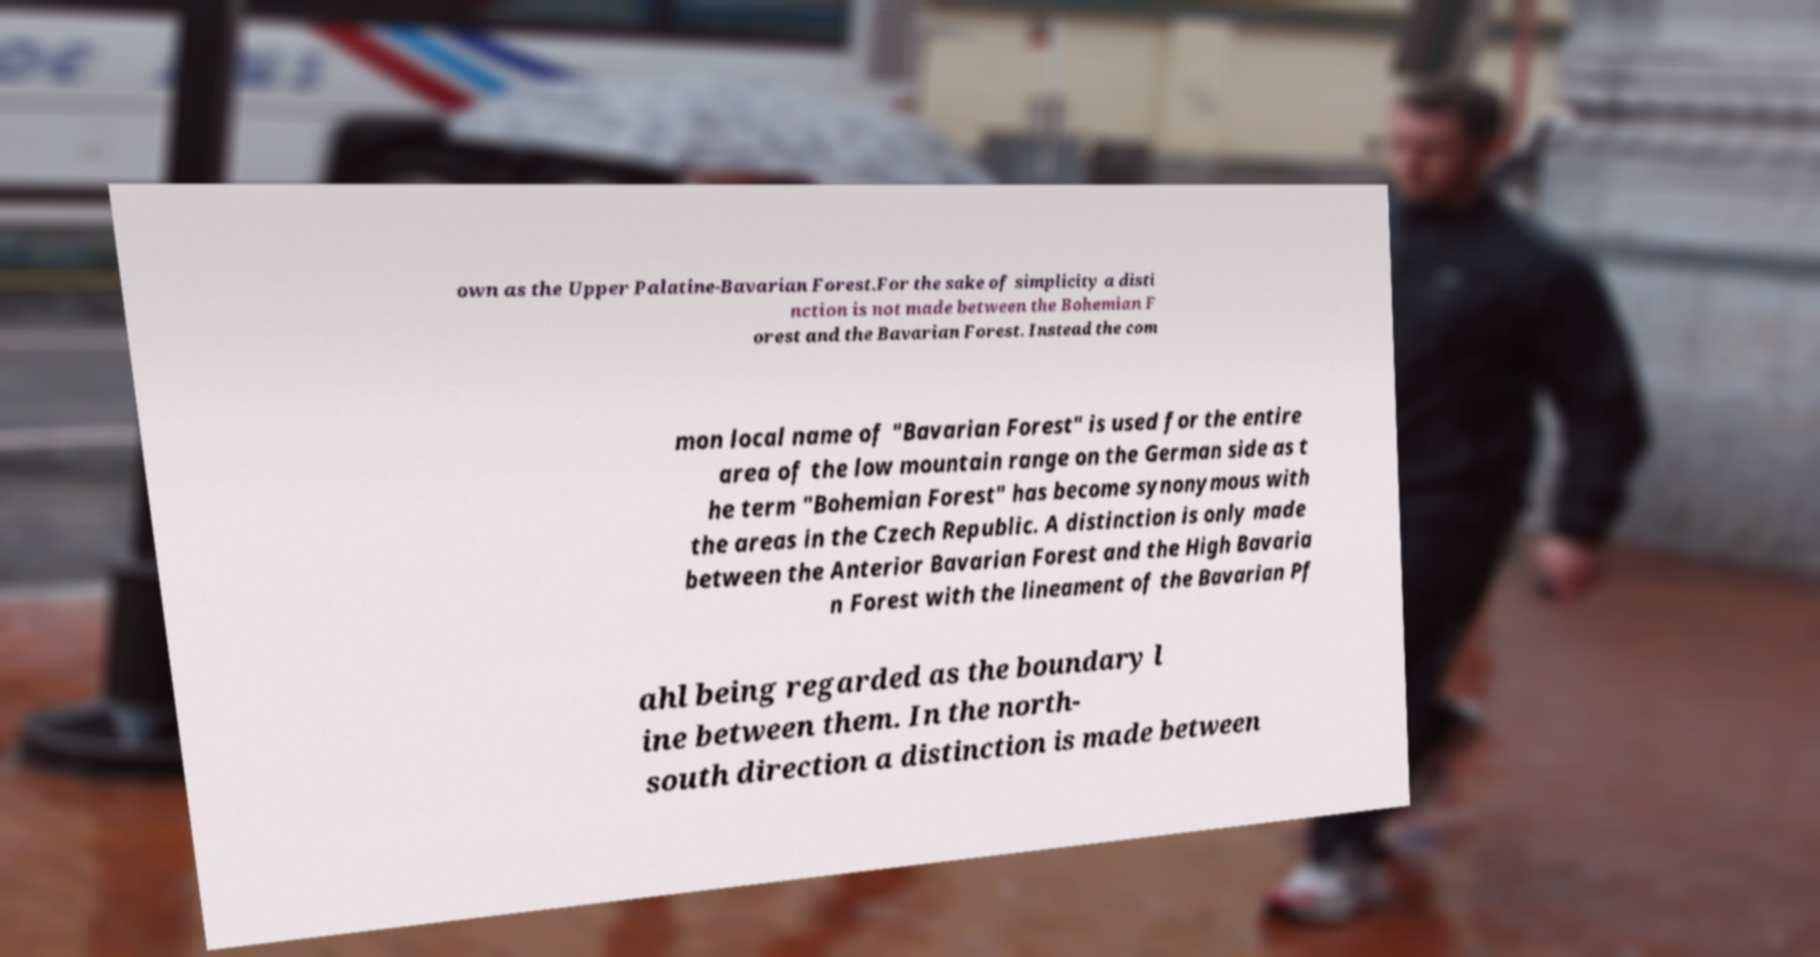Could you assist in decoding the text presented in this image and type it out clearly? own as the Upper Palatine-Bavarian Forest.For the sake of simplicity a disti nction is not made between the Bohemian F orest and the Bavarian Forest. Instead the com mon local name of "Bavarian Forest" is used for the entire area of the low mountain range on the German side as t he term "Bohemian Forest" has become synonymous with the areas in the Czech Republic. A distinction is only made between the Anterior Bavarian Forest and the High Bavaria n Forest with the lineament of the Bavarian Pf ahl being regarded as the boundary l ine between them. In the north- south direction a distinction is made between 